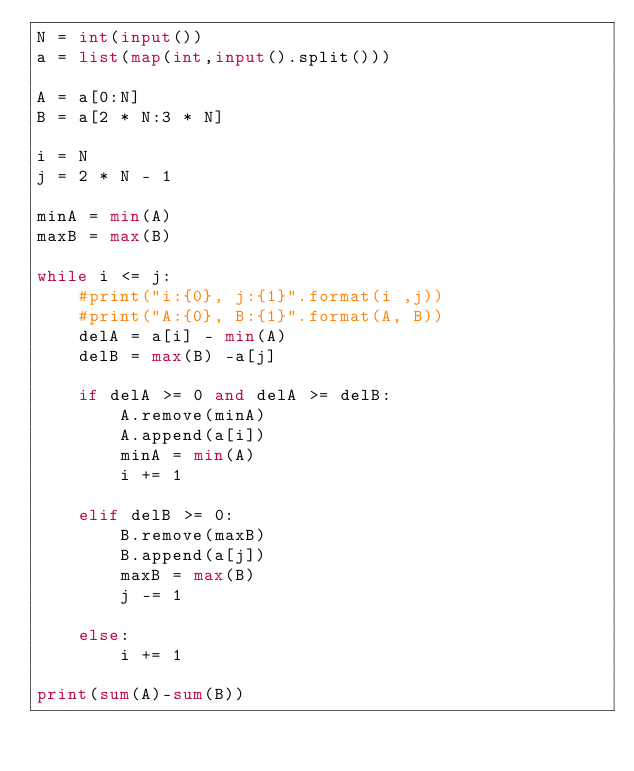<code> <loc_0><loc_0><loc_500><loc_500><_Python_>N = int(input())
a = list(map(int,input().split()))

A = a[0:N]
B = a[2 * N:3 * N]

i = N
j = 2 * N - 1

minA = min(A)
maxB = max(B)

while i <= j:
    #print("i:{0}, j:{1}".format(i ,j))
    #print("A:{0}, B:{1}".format(A, B))
    delA = a[i] - min(A)
    delB = max(B) -a[j]

    if delA >= 0 and delA >= delB:
        A.remove(minA)
        A.append(a[i])
        minA = min(A)
        i += 1

    elif delB >= 0:
        B.remove(maxB)
        B.append(a[j])
        maxB = max(B)
        j -= 1

    else:
        i += 1

print(sum(A)-sum(B))
</code> 